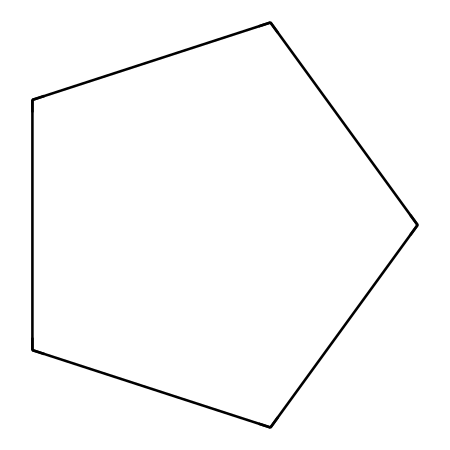How many carbon atoms are in Cyclopentane? The SMILES representation shows "C1CCCC1", which indicates a ring structure with five carbon atoms connected in a cycle. Each 'C' represents a carbon atom, and there are five of them in total.
Answer: five What type of chemical structure is indicated by the SMILES? The SMILES indicates a cyclic structure due to the "C1...C1" notation, which is characteristic of cycloalkanes. Cyclopentane specifically is a cycloalkane with a five-membered ring.
Answer: cycloalkane How many hydrogen atoms does Cyclopentane have? To find the number of hydrogen atoms in Cyclopentane, we can apply the general formula for cycloalkanes, CnH2n. Here n=5, so the number of hydrogen atoms is 2*5 = 10.
Answer: ten What is the bond type between the carbon atoms in Cyclopentane? The SMILES shows only carbon atoms connected by single bonds, which is typical for cycloalkanes. Since all bonds between carbon (C) atoms are single bonds, they are classified as sigma bonds.
Answer: single What is the significance of Cyclopentane in modernist lighting solutions? Cyclopentane serves as a solvent and can be used in producing certain types of plastics suitable for lighting design. Its physical properties allow it to create a lightweight and durable framework.
Answer: solvent What properties help Cyclopentane in terms of electrical insulation? Cyclopentane has a low dielectric constant and good thermal stability, which are favorable characteristics in insulating materials used in lighting solutions.
Answer: low dielectric constant How does the structure of Cyclopentane affect its boiling point? The closed cyclic structure gives Cyclopentane a relatively lower boiling point compared to straight-chain alkanes of similar molecular weight due to less surface area for intermolecular interactions.
Answer: lower boiling point 